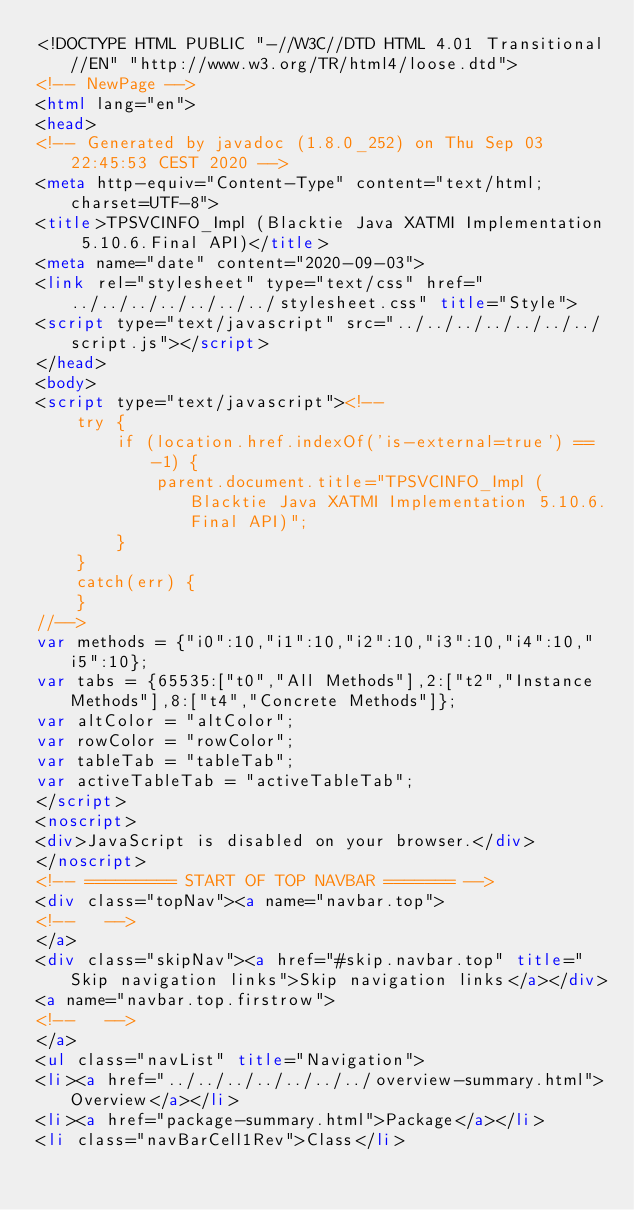Convert code to text. <code><loc_0><loc_0><loc_500><loc_500><_HTML_><!DOCTYPE HTML PUBLIC "-//W3C//DTD HTML 4.01 Transitional//EN" "http://www.w3.org/TR/html4/loose.dtd">
<!-- NewPage -->
<html lang="en">
<head>
<!-- Generated by javadoc (1.8.0_252) on Thu Sep 03 22:45:53 CEST 2020 -->
<meta http-equiv="Content-Type" content="text/html; charset=UTF-8">
<title>TPSVCINFO_Impl (Blacktie Java XATMI Implementation 5.10.6.Final API)</title>
<meta name="date" content="2020-09-03">
<link rel="stylesheet" type="text/css" href="../../../../../../../stylesheet.css" title="Style">
<script type="text/javascript" src="../../../../../../../script.js"></script>
</head>
<body>
<script type="text/javascript"><!--
    try {
        if (location.href.indexOf('is-external=true') == -1) {
            parent.document.title="TPSVCINFO_Impl (Blacktie Java XATMI Implementation 5.10.6.Final API)";
        }
    }
    catch(err) {
    }
//-->
var methods = {"i0":10,"i1":10,"i2":10,"i3":10,"i4":10,"i5":10};
var tabs = {65535:["t0","All Methods"],2:["t2","Instance Methods"],8:["t4","Concrete Methods"]};
var altColor = "altColor";
var rowColor = "rowColor";
var tableTab = "tableTab";
var activeTableTab = "activeTableTab";
</script>
<noscript>
<div>JavaScript is disabled on your browser.</div>
</noscript>
<!-- ========= START OF TOP NAVBAR ======= -->
<div class="topNav"><a name="navbar.top">
<!--   -->
</a>
<div class="skipNav"><a href="#skip.navbar.top" title="Skip navigation links">Skip navigation links</a></div>
<a name="navbar.top.firstrow">
<!--   -->
</a>
<ul class="navList" title="Navigation">
<li><a href="../../../../../../../overview-summary.html">Overview</a></li>
<li><a href="package-summary.html">Package</a></li>
<li class="navBarCell1Rev">Class</li></code> 